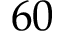Convert formula to latex. <formula><loc_0><loc_0><loc_500><loc_500>6 0</formula> 